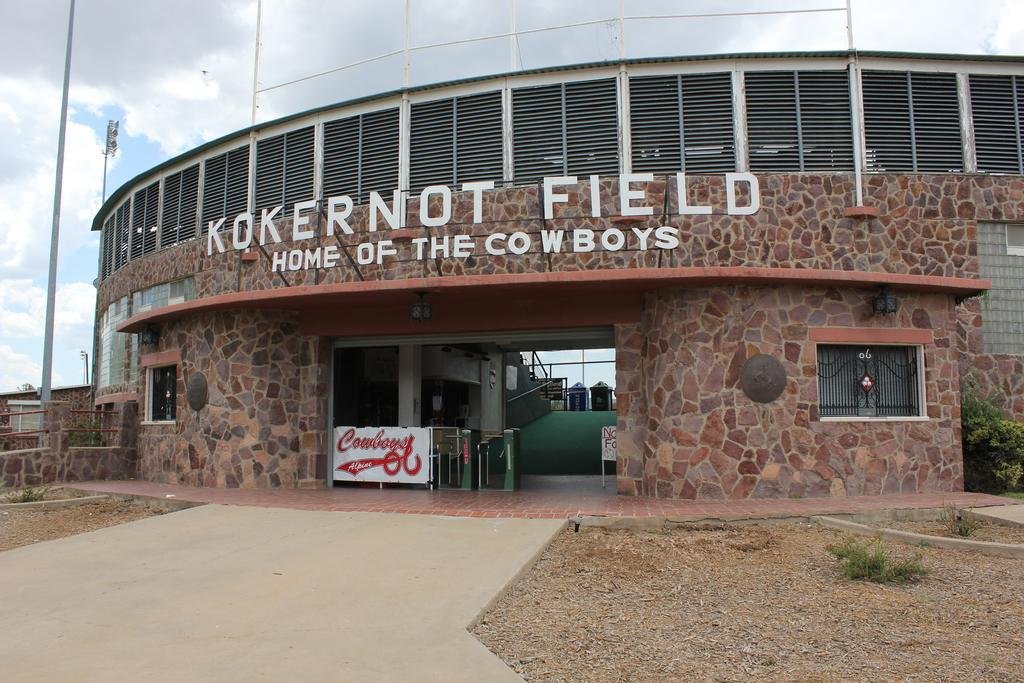Please provide a concise description of this image. In this picture we can see a building, in the building we can find a hoarding and a notice board, beside to the building we can see few plants, poles, metal rods and a house. 